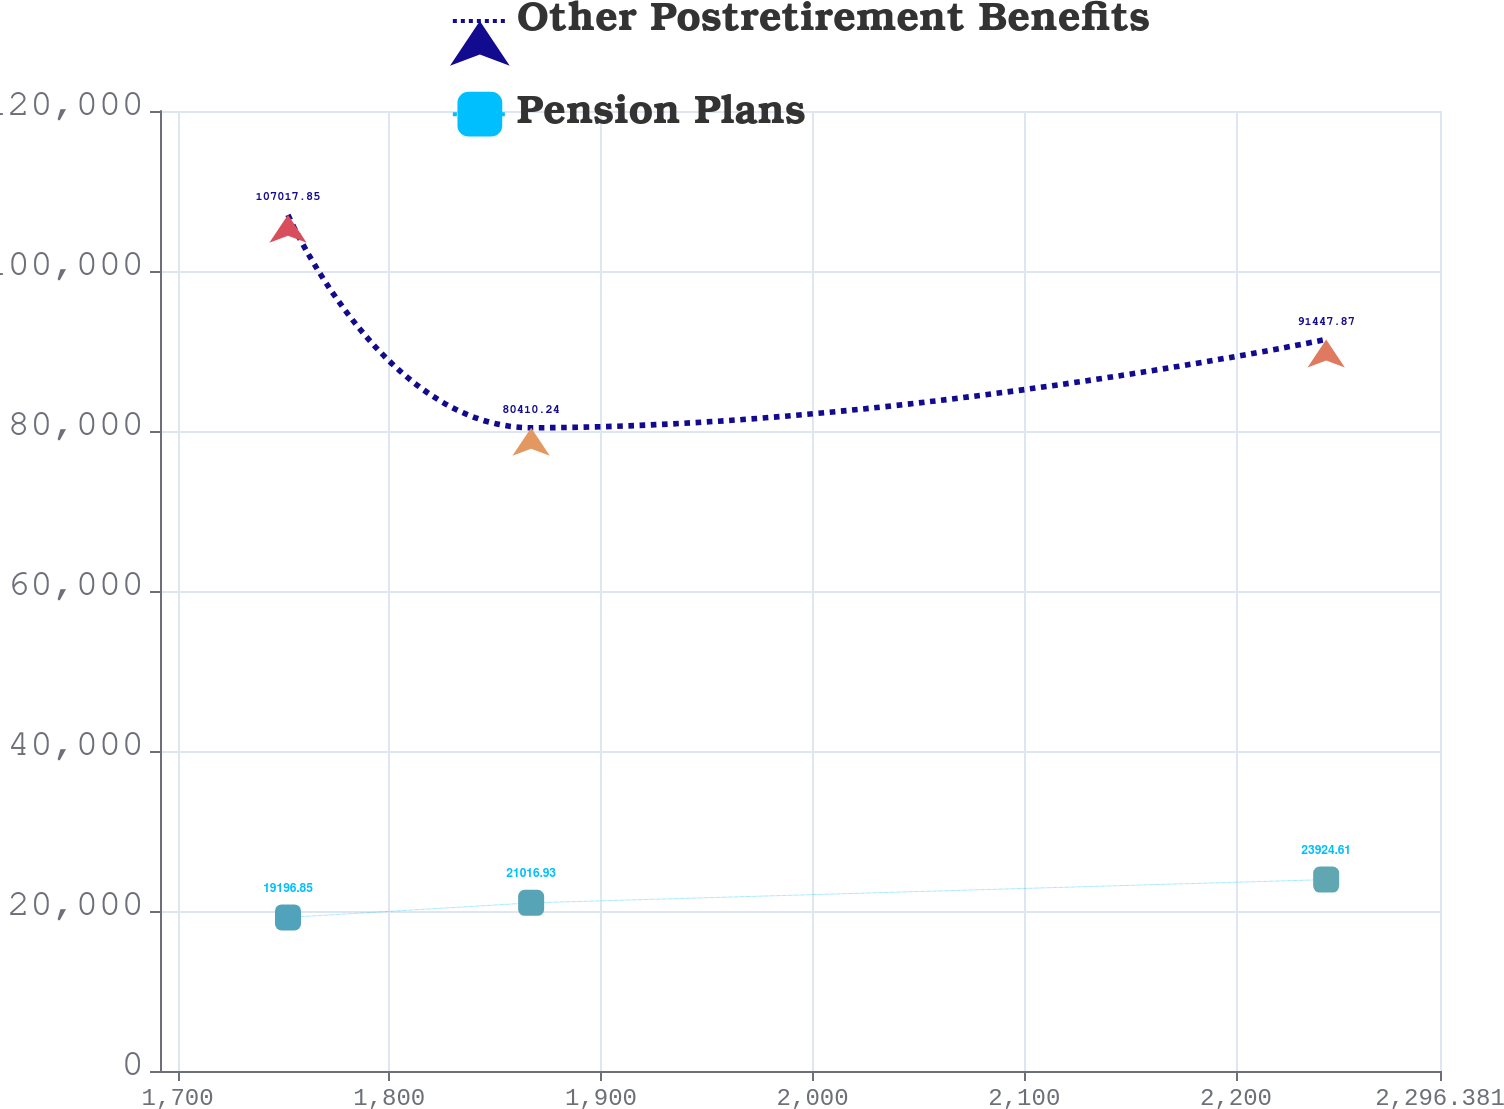Convert chart to OTSL. <chart><loc_0><loc_0><loc_500><loc_500><line_chart><ecel><fcel>Other Postretirement Benefits<fcel>Pension Plans<nl><fcel>1752.16<fcel>107018<fcel>19196.8<nl><fcel>1867.02<fcel>80410.2<fcel>21016.9<nl><fcel>2242.61<fcel>91447.9<fcel>23924.6<nl><fcel>2299.73<fcel>83353.9<fcel>23161.6<nl><fcel>2356.85<fcel>86014.7<fcel>21489.7<nl></chart> 